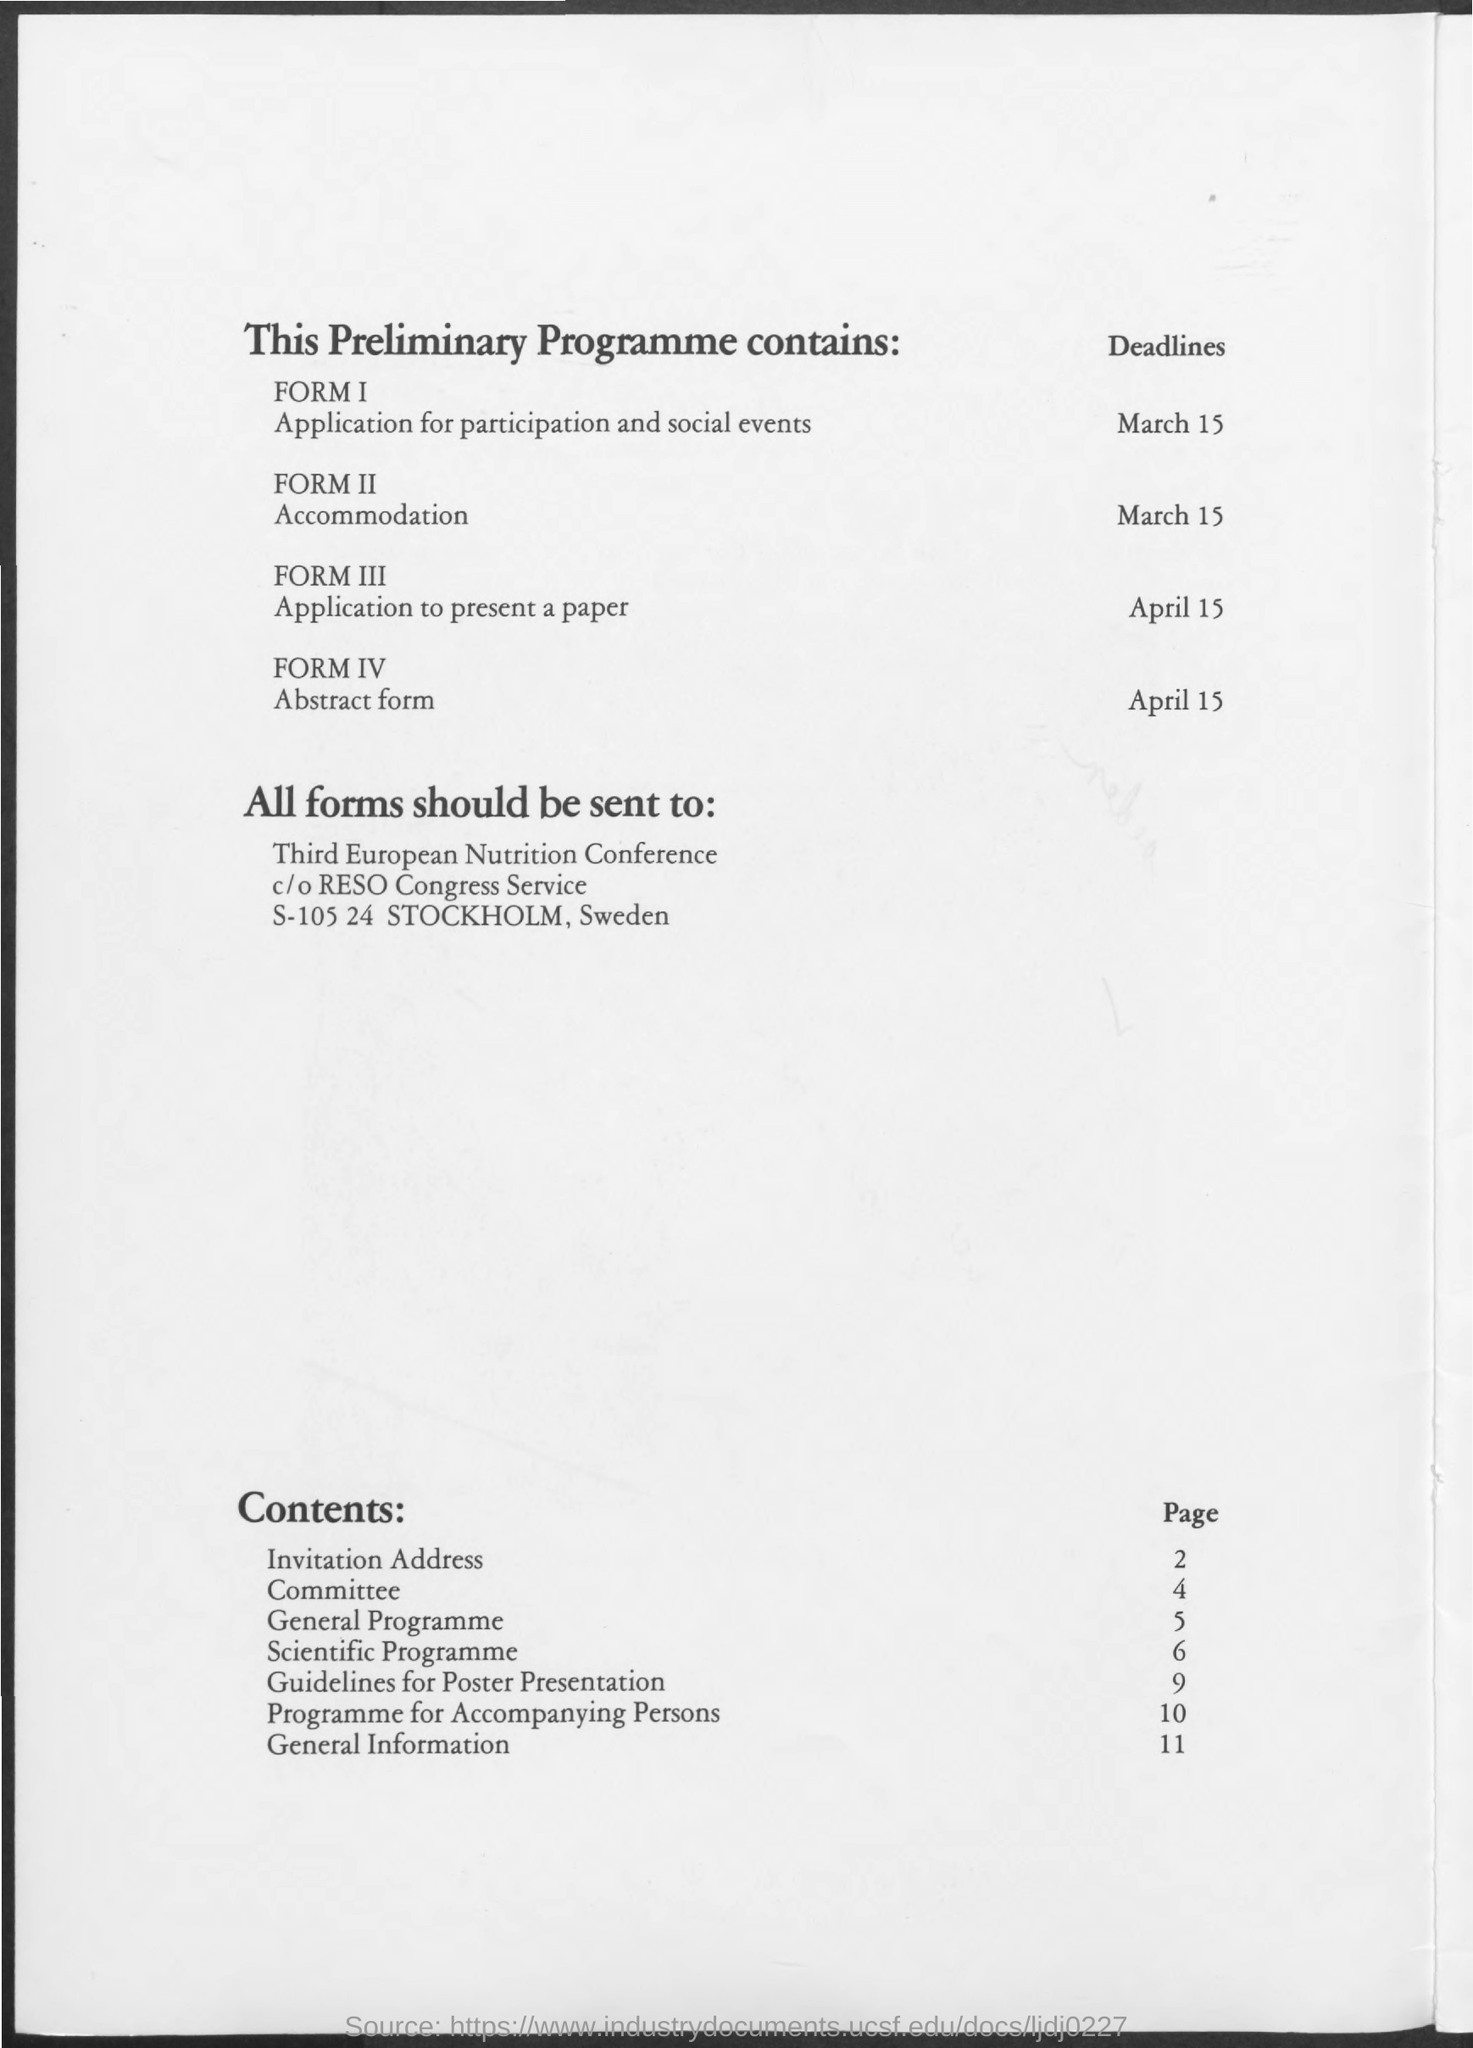What is the deadline for application for participation and social events?
Keep it short and to the point. March 15. What form must be filled for application for participation and social events?
Give a very brief answer. Form I. What is the deadline for accommodation?
Your answer should be very brief. March 15. What form must be filled for accommodation?
Ensure brevity in your answer.  Form II. What is deadline for application to present a paper?
Make the answer very short. April 15. What is the deadline for abstract  form?
Give a very brief answer. April 15. What is the page number for general programme?
Ensure brevity in your answer.  5. What is the page number for general information?
Your answer should be very brief. 11. 